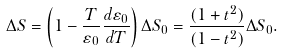<formula> <loc_0><loc_0><loc_500><loc_500>\Delta S = \left ( 1 - \frac { T } { \varepsilon _ { 0 } } \frac { d \varepsilon _ { 0 } } { d T } \right ) \Delta S _ { 0 } = \frac { ( 1 + t ^ { 2 } ) } { ( 1 - t ^ { 2 } ) } \Delta S _ { 0 } .</formula> 